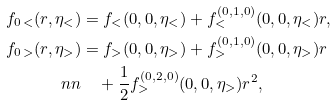Convert formula to latex. <formula><loc_0><loc_0><loc_500><loc_500>f _ { 0 \, < } ( r , \eta _ { < } ) & = f _ { < } ( 0 , 0 , \eta _ { < } ) + f ^ { ( 0 , 1 , 0 ) } _ { < } ( 0 , 0 , \eta _ { < } ) r , \\ f _ { 0 \, > } ( r , \eta _ { > } ) & = f _ { > } ( 0 , 0 , \eta _ { > } ) + f ^ { ( 0 , 1 , 0 ) } _ { > } ( 0 , 0 , \eta _ { > } ) r \\ \ n n & \quad + \frac { 1 } { 2 } f ^ { ( 0 , 2 , 0 ) } _ { > } ( 0 , 0 , \eta _ { > } ) r ^ { 2 } ,</formula> 